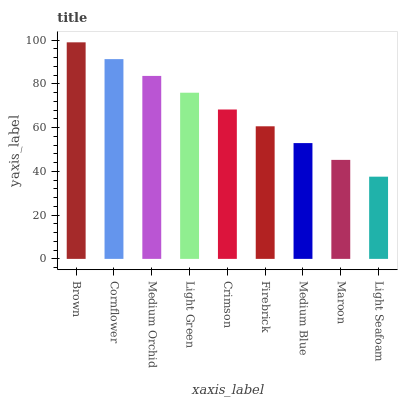Is Light Seafoam the minimum?
Answer yes or no. Yes. Is Brown the maximum?
Answer yes or no. Yes. Is Cornflower the minimum?
Answer yes or no. No. Is Cornflower the maximum?
Answer yes or no. No. Is Brown greater than Cornflower?
Answer yes or no. Yes. Is Cornflower less than Brown?
Answer yes or no. Yes. Is Cornflower greater than Brown?
Answer yes or no. No. Is Brown less than Cornflower?
Answer yes or no. No. Is Crimson the high median?
Answer yes or no. Yes. Is Crimson the low median?
Answer yes or no. Yes. Is Maroon the high median?
Answer yes or no. No. Is Maroon the low median?
Answer yes or no. No. 